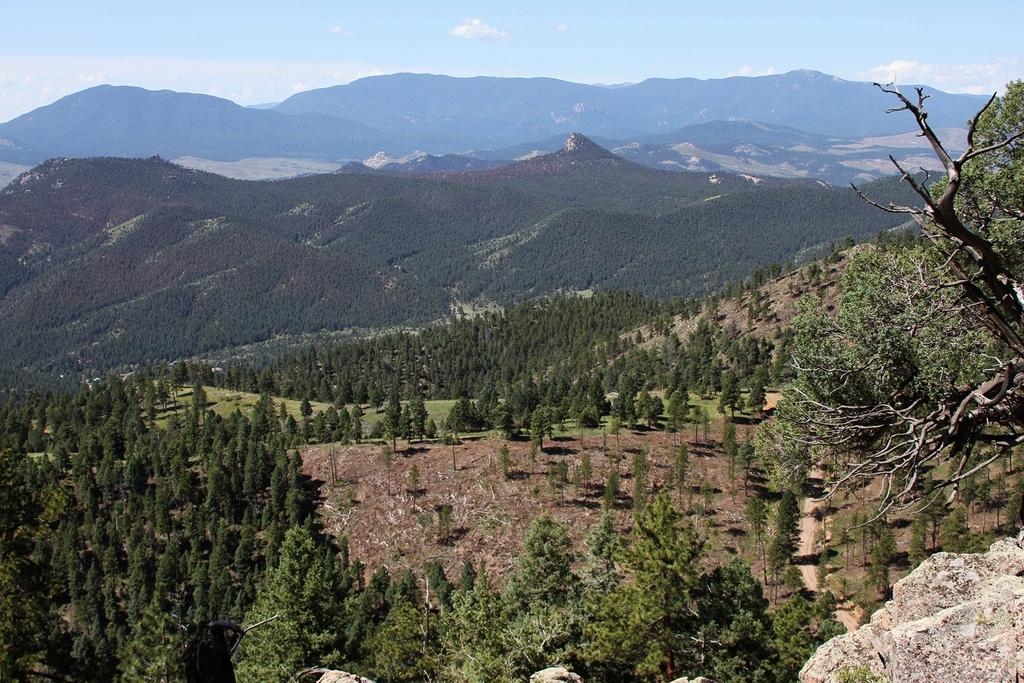What is located in the right bottom corner of the image? There is a stone and a tree in the right bottom corner of the image. What can be seen in the background of the image? There are trees, grass, mountains, and clouds in the sky in the background of the image. Is there any path visible in the image? Yes, there is a path on the right side of the image. How many giants are holding the soup in the image? There are no giants or soup present in the image. What type of crook can be seen in the image? There is no crook present in the image. 